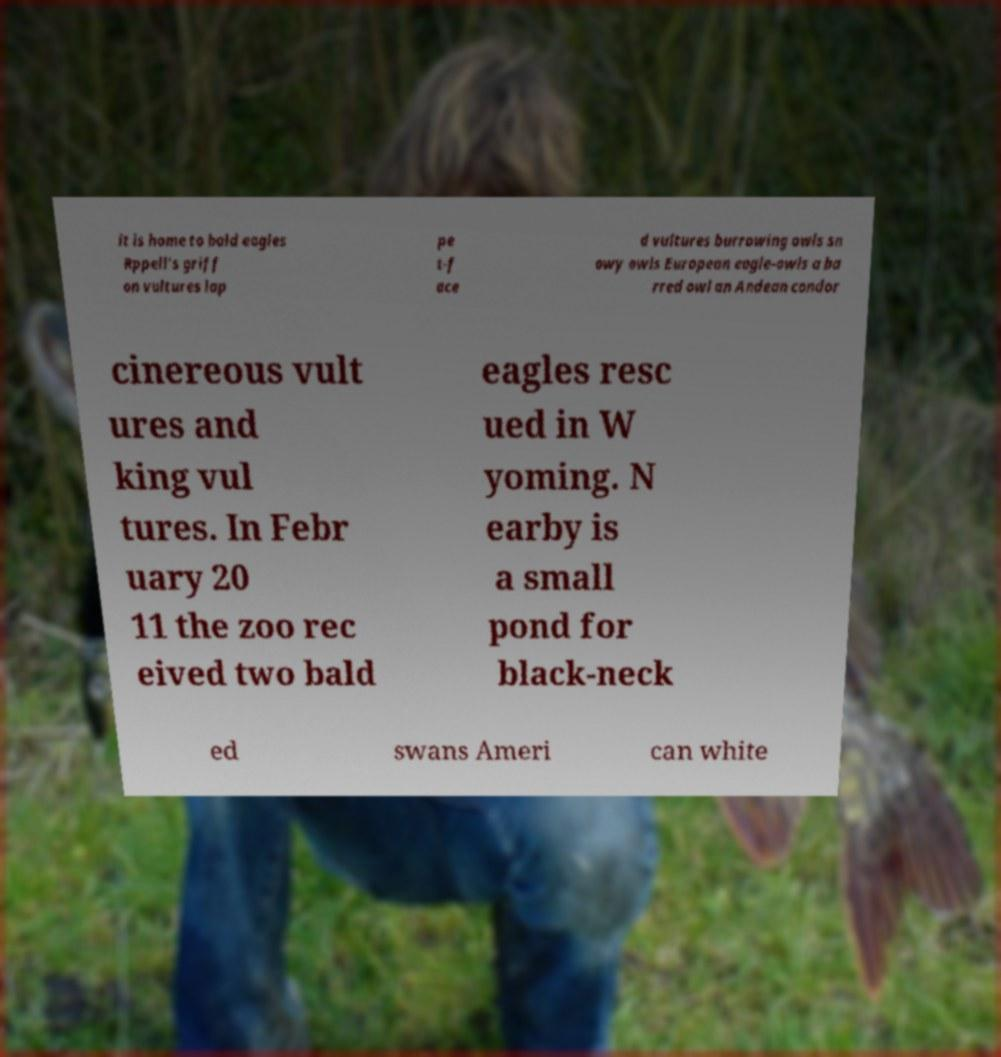For documentation purposes, I need the text within this image transcribed. Could you provide that? it is home to bald eagles Rppell's griff on vultures lap pe t-f ace d vultures burrowing owls sn owy owls European eagle-owls a ba rred owl an Andean condor cinereous vult ures and king vul tures. In Febr uary 20 11 the zoo rec eived two bald eagles resc ued in W yoming. N earby is a small pond for black-neck ed swans Ameri can white 